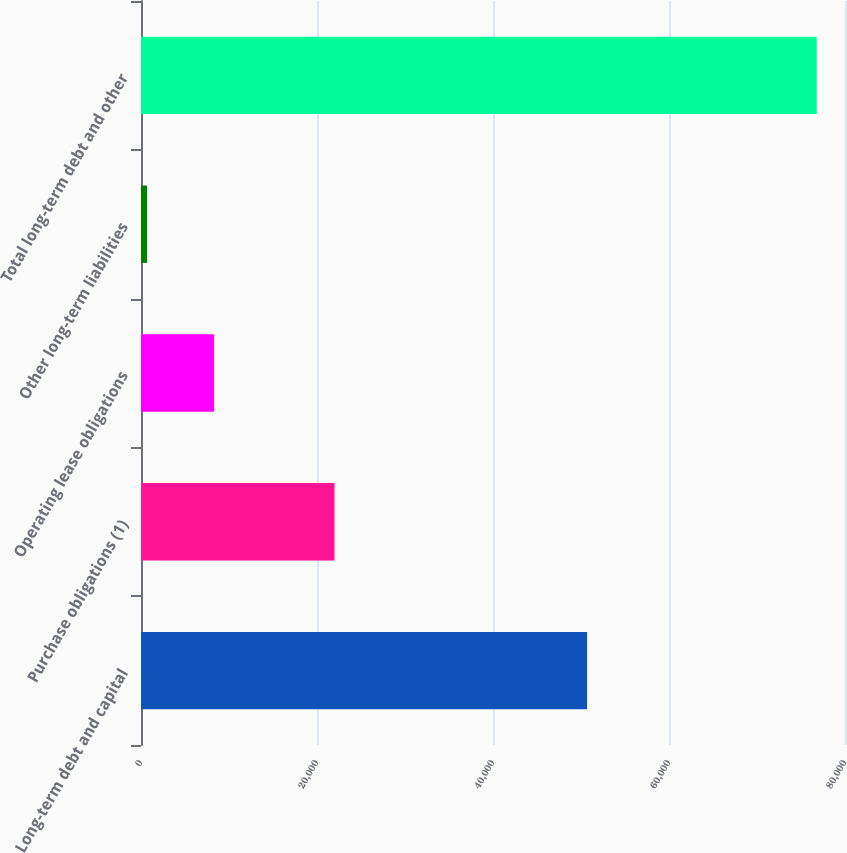Convert chart to OTSL. <chart><loc_0><loc_0><loc_500><loc_500><bar_chart><fcel>Long-term debt and capital<fcel>Purchase obligations (1)<fcel>Operating lease obligations<fcel>Other long-term liabilities<fcel>Total long-term debt and other<nl><fcel>50693<fcel>21994<fcel>8303.2<fcel>694<fcel>76786<nl></chart> 